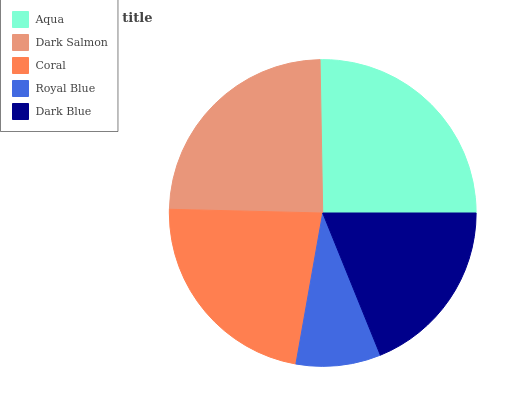Is Royal Blue the minimum?
Answer yes or no. Yes. Is Aqua the maximum?
Answer yes or no. Yes. Is Dark Salmon the minimum?
Answer yes or no. No. Is Dark Salmon the maximum?
Answer yes or no. No. Is Aqua greater than Dark Salmon?
Answer yes or no. Yes. Is Dark Salmon less than Aqua?
Answer yes or no. Yes. Is Dark Salmon greater than Aqua?
Answer yes or no. No. Is Aqua less than Dark Salmon?
Answer yes or no. No. Is Coral the high median?
Answer yes or no. Yes. Is Coral the low median?
Answer yes or no. Yes. Is Royal Blue the high median?
Answer yes or no. No. Is Dark Salmon the low median?
Answer yes or no. No. 